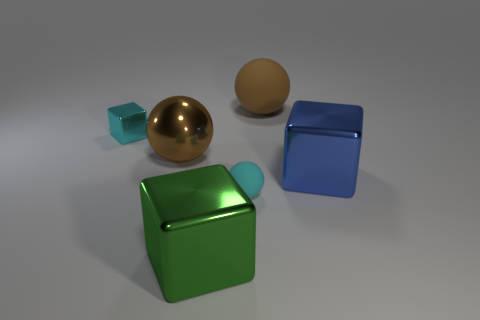Add 4 blue metal cylinders. How many objects exist? 10 Subtract 0 brown cubes. How many objects are left? 6 Subtract all small cyan rubber balls. Subtract all big objects. How many objects are left? 1 Add 1 blocks. How many blocks are left? 4 Add 4 brown metallic cubes. How many brown metallic cubes exist? 4 